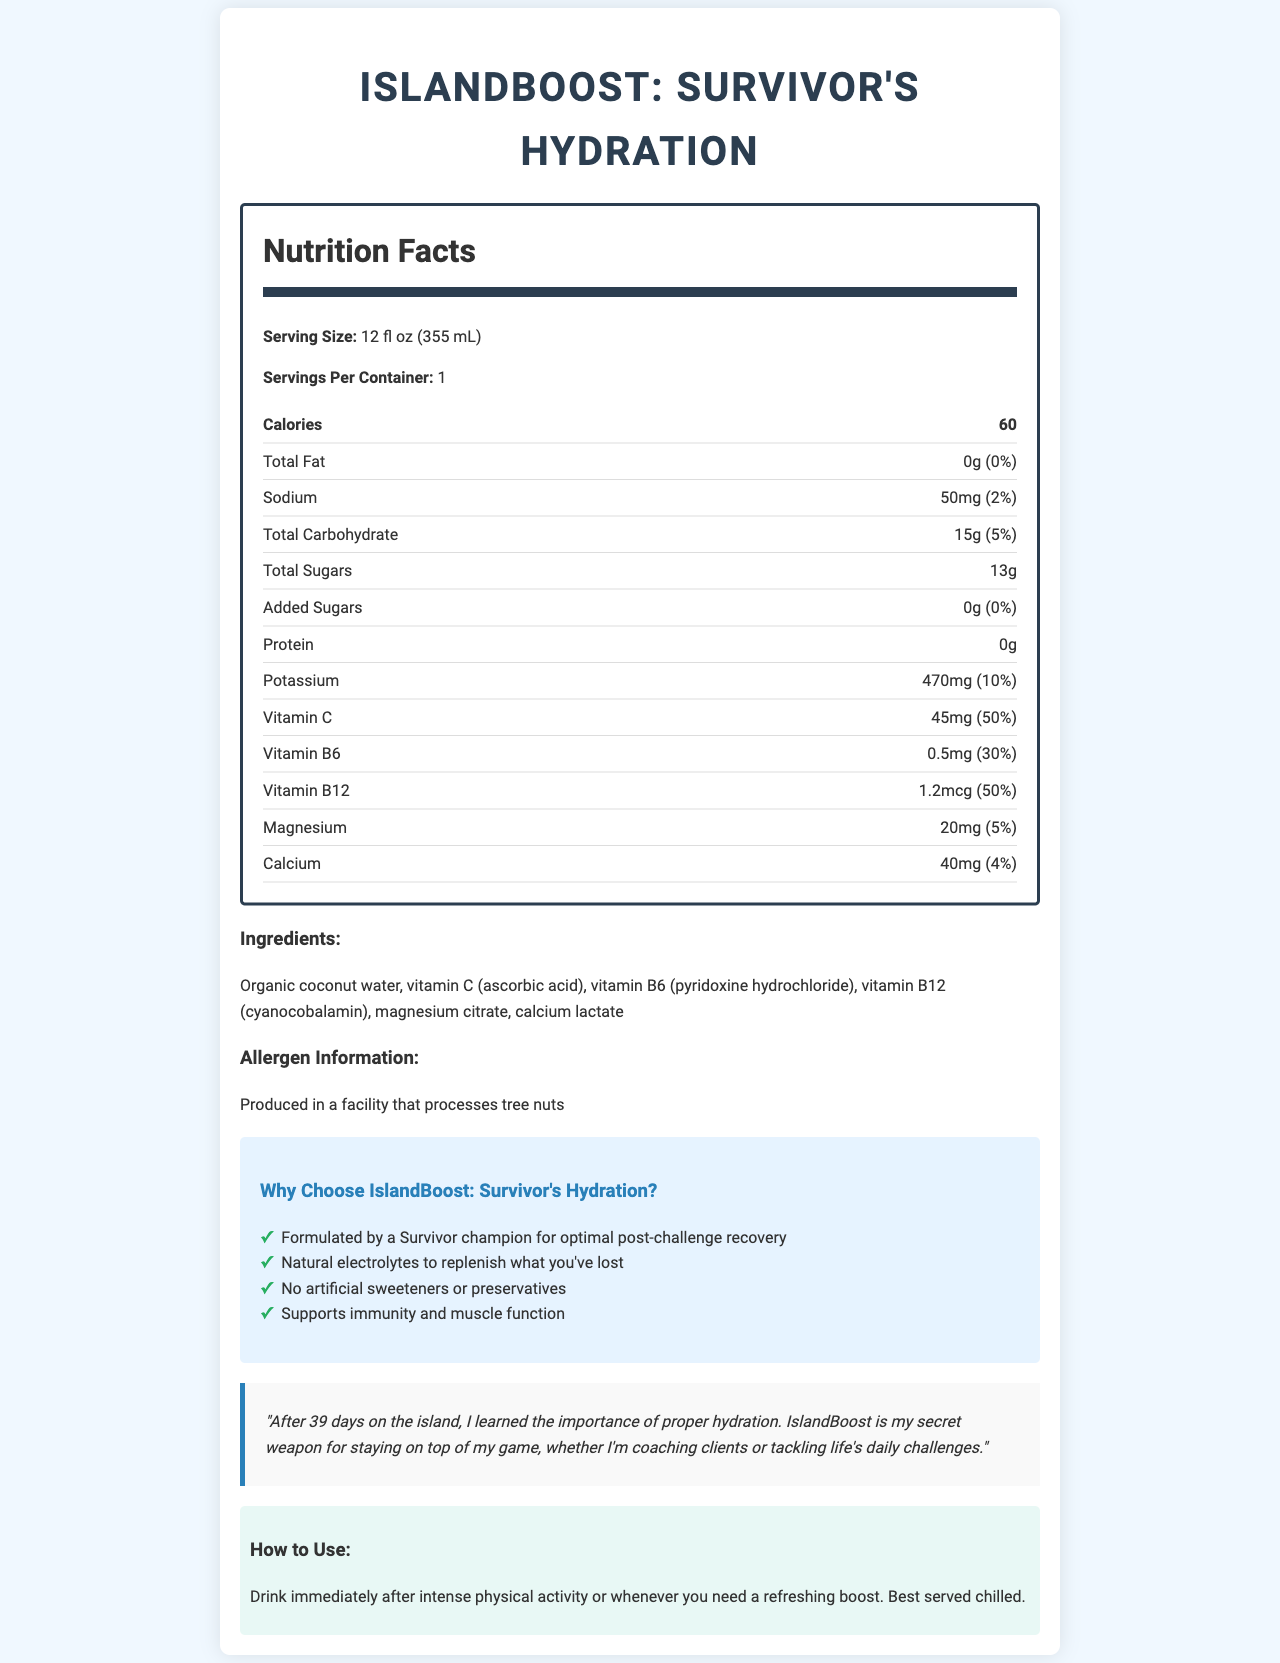what is the serving size? The serving size is directly mentioned in the document under the Nutrition Facts section as "Serving Size: 12 fl oz (355 mL)".
Answer: 12 fl oz (355 mL) how many calories are in one serving? The document states the number of calories per serving right below the serving size: "Calories: 60".
Answer: 60 calories what is the amount of total sugars in this product? The amount of total sugars is listed under the Nutrition Facts section with the label "Total Sugars: 13g".
Answer: 13g how much potassium is in one serving? The amount of potassium per serving is displayed under the Nutrition Facts section as "Potassium: 470mg".
Answer: 470mg how much vitamin C does this drink provide per serving? The amount of vitamin C per serving is directly mentioned in the Nutrition Facts: "Vitamin C: 45mg".
Answer: 45mg what are the main ingredients of the drink? The ingredients are specified in the document under the Ingredients section.
Answer: Organic coconut water, vitamin C (ascorbic acid), vitamin B6 (pyridoxine hydrochloride), vitamin B12 (cyanocobalamin), magnesium citrate, calcium lactate where is IslandBoost produced in terms of allergen information? The allergen information section states that the product is produced in a facility that processes tree nuts.
Answer: In a facility that processes tree nuts how much sodium is in one serving? A. 0mg B. 25mg C. 50mg D. 100mg The document mentions this in the Nutrition Facts section: "Sodium: 50mg".
Answer: C. 50mg what is the marketing claim of this product related to muscle function? A. Supports immunity B. Supports muscle function C. All-natural D. Low-calorie The marketing section lists "Supports immunity and muscle function" as one of the claims.
Answer: B. Supports muscle function does this drink contain any artificial sweeteners? The marketing claims section clearly states "No artificial sweeteners or preservatives".
Answer: No can this drink be used for pre-workout hydration? The usage instructions specify the drink is for post-workout hydration or whenever you need a refreshing boost. It does not mention pre-workout usage.
Answer: Not enough information describe the main idea of the document. The document includes comprehensive details about the drink, its nutritional values, ingredients, and benefits, emphasizing its natural ingredients and suitability for post-workout recovery. The testimonial and usage instructions also support this main idea.
Answer: The main idea of the document is to provide detailed information about "IslandBoost: Survivor's Hydration", including its nutritional facts, ingredients, allergen info, marketing claims, and usage instructions. The product is marketed as a post-workout hydration drink formulated by a Survivor champion, aimed at recovery and hydration without artificial additives. 